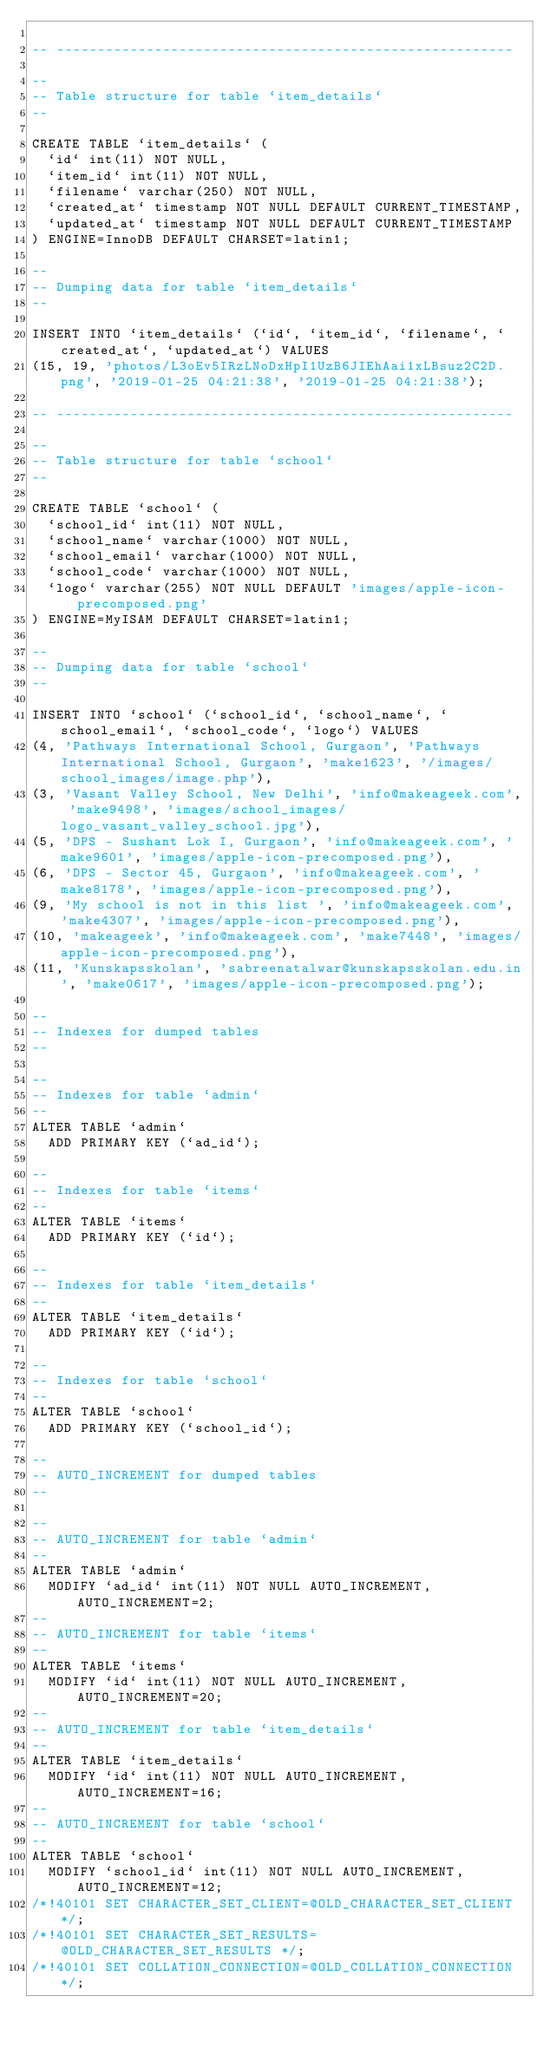<code> <loc_0><loc_0><loc_500><loc_500><_SQL_>
-- --------------------------------------------------------

--
-- Table structure for table `item_details`
--

CREATE TABLE `item_details` (
  `id` int(11) NOT NULL,
  `item_id` int(11) NOT NULL,
  `filename` varchar(250) NOT NULL,
  `created_at` timestamp NOT NULL DEFAULT CURRENT_TIMESTAMP,
  `updated_at` timestamp NOT NULL DEFAULT CURRENT_TIMESTAMP
) ENGINE=InnoDB DEFAULT CHARSET=latin1;

--
-- Dumping data for table `item_details`
--

INSERT INTO `item_details` (`id`, `item_id`, `filename`, `created_at`, `updated_at`) VALUES
(15, 19, 'photos/L3oEv5IRzLNoDxHpI1UzB6JIEhAai1xLBsuz2C2D.png', '2019-01-25 04:21:38', '2019-01-25 04:21:38');

-- --------------------------------------------------------

--
-- Table structure for table `school`
--

CREATE TABLE `school` (
  `school_id` int(11) NOT NULL,
  `school_name` varchar(1000) NOT NULL,
  `school_email` varchar(1000) NOT NULL,
  `school_code` varchar(1000) NOT NULL,
  `logo` varchar(255) NOT NULL DEFAULT 'images/apple-icon-precomposed.png'
) ENGINE=MyISAM DEFAULT CHARSET=latin1;

--
-- Dumping data for table `school`
--

INSERT INTO `school` (`school_id`, `school_name`, `school_email`, `school_code`, `logo`) VALUES
(4, 'Pathways International School, Gurgaon', 'Pathways International School, Gurgaon', 'make1623', '/images/school_images/image.php'),
(3, 'Vasant Valley School, New Delhi', 'info@makeageek.com', 'make9498', 'images/school_images/logo_vasant_valley_school.jpg'),
(5, 'DPS - Sushant Lok I, Gurgaon', 'info@makeageek.com', 'make9601', 'images/apple-icon-precomposed.png'),
(6, 'DPS - Sector 45, Gurgaon', 'info@makeageek.com', 'make8178', 'images/apple-icon-precomposed.png'),
(9, 'My school is not in this list ', 'info@makeageek.com', 'make4307', 'images/apple-icon-precomposed.png'),
(10, 'makeageek', 'info@makeageek.com', 'make7448', 'images/apple-icon-precomposed.png'),
(11, 'Kunskapsskolan', 'sabreenatalwar@kunskapsskolan.edu.in', 'make0617', 'images/apple-icon-precomposed.png');

--
-- Indexes for dumped tables
--

--
-- Indexes for table `admin`
--
ALTER TABLE `admin`
  ADD PRIMARY KEY (`ad_id`);

--
-- Indexes for table `items`
--
ALTER TABLE `items`
  ADD PRIMARY KEY (`id`);

--
-- Indexes for table `item_details`
--
ALTER TABLE `item_details`
  ADD PRIMARY KEY (`id`);

--
-- Indexes for table `school`
--
ALTER TABLE `school`
  ADD PRIMARY KEY (`school_id`);

--
-- AUTO_INCREMENT for dumped tables
--

--
-- AUTO_INCREMENT for table `admin`
--
ALTER TABLE `admin`
  MODIFY `ad_id` int(11) NOT NULL AUTO_INCREMENT, AUTO_INCREMENT=2;
--
-- AUTO_INCREMENT for table `items`
--
ALTER TABLE `items`
  MODIFY `id` int(11) NOT NULL AUTO_INCREMENT, AUTO_INCREMENT=20;
--
-- AUTO_INCREMENT for table `item_details`
--
ALTER TABLE `item_details`
  MODIFY `id` int(11) NOT NULL AUTO_INCREMENT, AUTO_INCREMENT=16;
--
-- AUTO_INCREMENT for table `school`
--
ALTER TABLE `school`
  MODIFY `school_id` int(11) NOT NULL AUTO_INCREMENT, AUTO_INCREMENT=12;
/*!40101 SET CHARACTER_SET_CLIENT=@OLD_CHARACTER_SET_CLIENT */;
/*!40101 SET CHARACTER_SET_RESULTS=@OLD_CHARACTER_SET_RESULTS */;
/*!40101 SET COLLATION_CONNECTION=@OLD_COLLATION_CONNECTION */;
</code> 